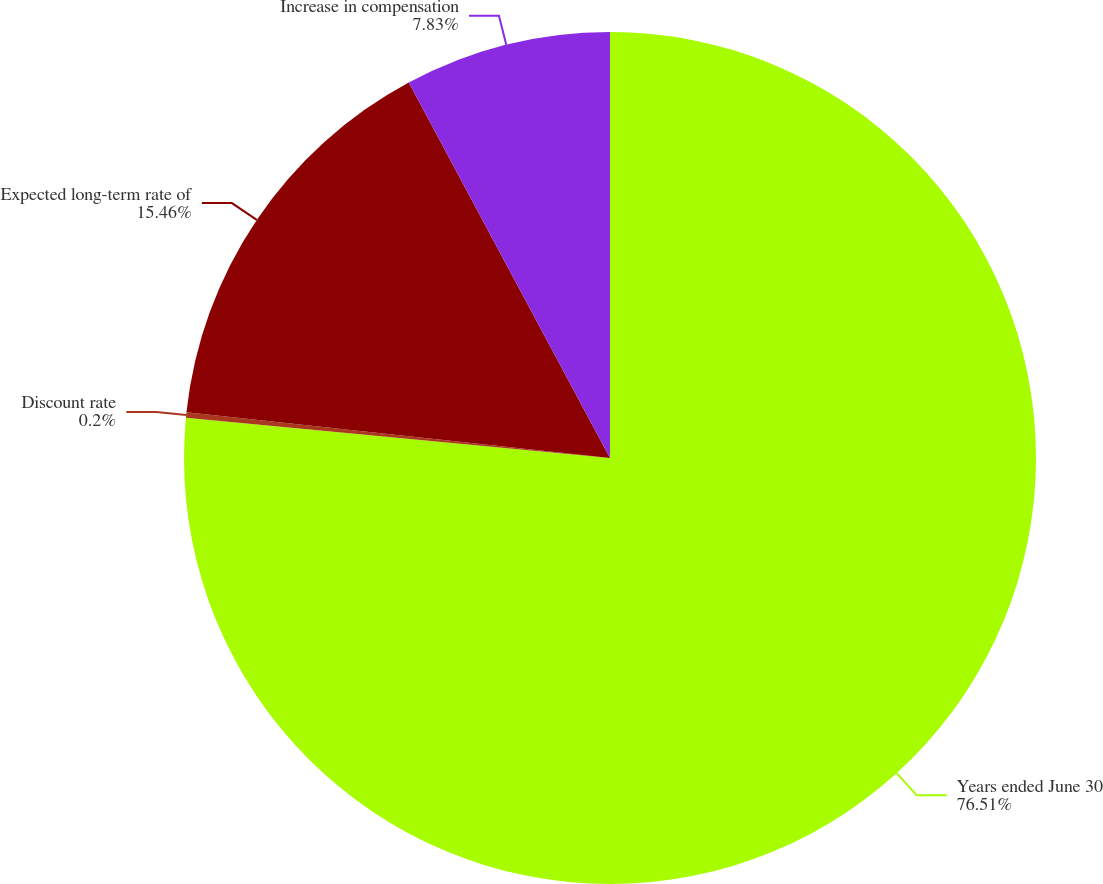Convert chart to OTSL. <chart><loc_0><loc_0><loc_500><loc_500><pie_chart><fcel>Years ended June 30<fcel>Discount rate<fcel>Expected long-term rate of<fcel>Increase in compensation<nl><fcel>76.51%<fcel>0.2%<fcel>15.46%<fcel>7.83%<nl></chart> 